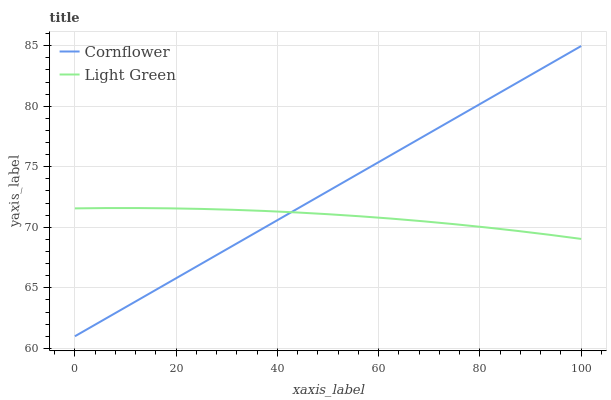Does Light Green have the minimum area under the curve?
Answer yes or no. Yes. Does Cornflower have the maximum area under the curve?
Answer yes or no. Yes. Does Light Green have the maximum area under the curve?
Answer yes or no. No. Is Cornflower the smoothest?
Answer yes or no. Yes. Is Light Green the roughest?
Answer yes or no. Yes. Is Light Green the smoothest?
Answer yes or no. No. Does Cornflower have the lowest value?
Answer yes or no. Yes. Does Light Green have the lowest value?
Answer yes or no. No. Does Cornflower have the highest value?
Answer yes or no. Yes. Does Light Green have the highest value?
Answer yes or no. No. Does Cornflower intersect Light Green?
Answer yes or no. Yes. Is Cornflower less than Light Green?
Answer yes or no. No. Is Cornflower greater than Light Green?
Answer yes or no. No. 